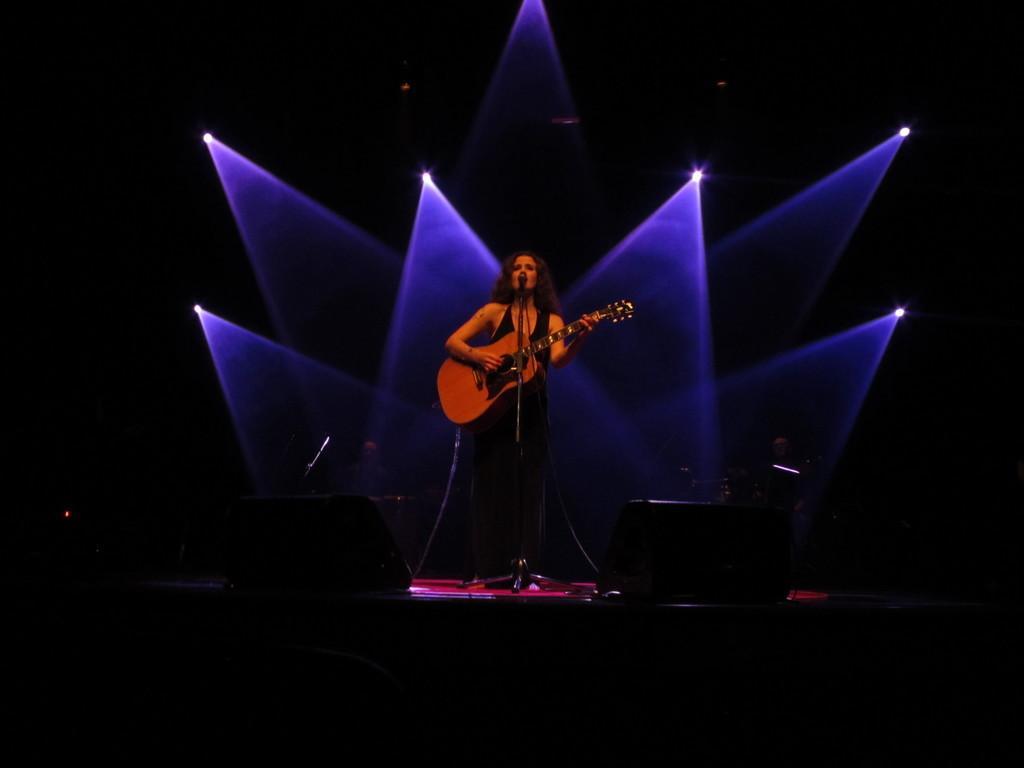In one or two sentences, can you explain what this image depicts? In the middle there is a woman , her hair is short she is playing guitar ,In front of her there is a mic. At the bottom there are speakers. In the background there are many lights. This is a stage performance. 